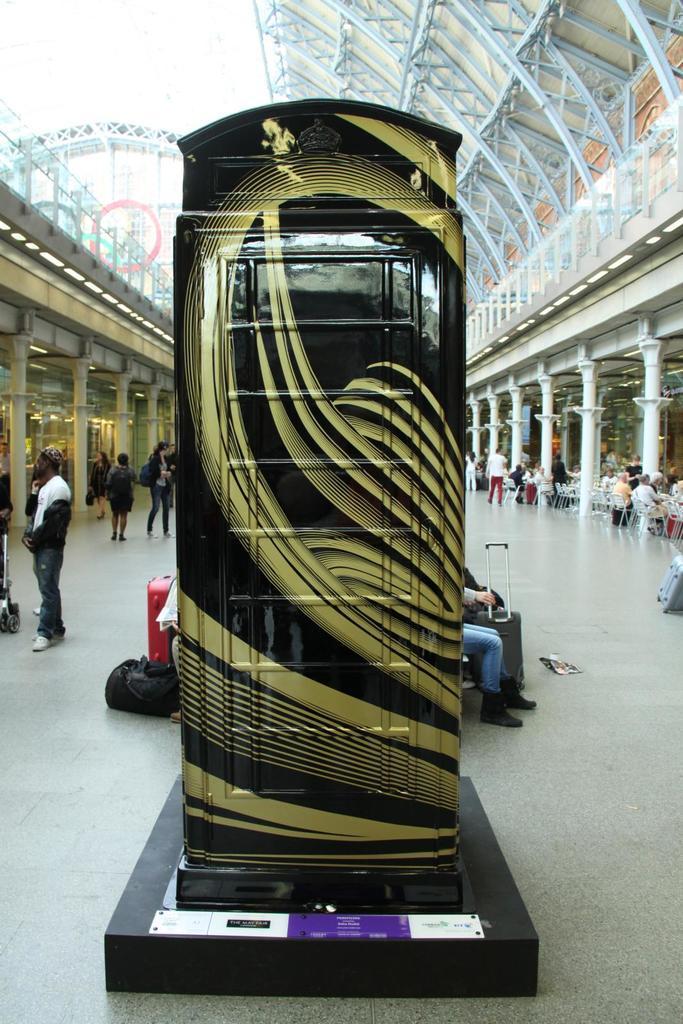In one or two sentences, can you explain what this image depicts? In the left side a man is standing and few people are walking. 